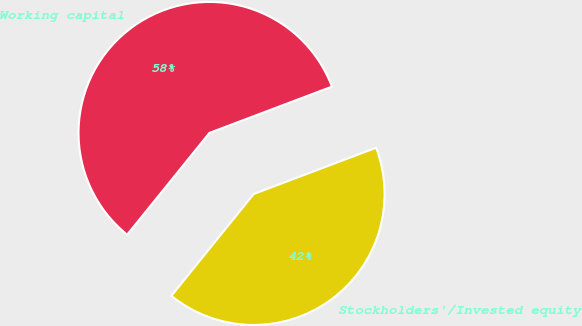<chart> <loc_0><loc_0><loc_500><loc_500><pie_chart><fcel>Working capital<fcel>Stockholders'/Invested equity<nl><fcel>58.43%<fcel>41.57%<nl></chart> 